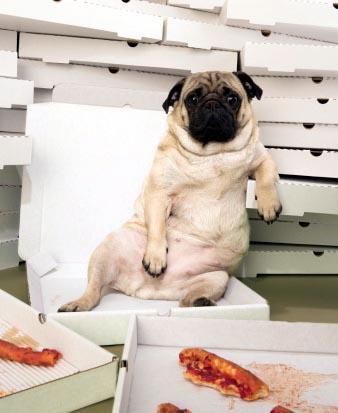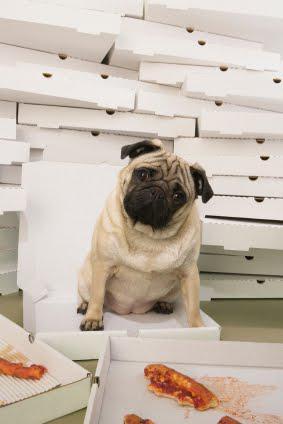The first image is the image on the left, the second image is the image on the right. Examine the images to the left and right. Is the description "There is a pug eating a slice of pizza, and another pug not eating a slice of pizza." accurate? Answer yes or no. No. The first image is the image on the left, the second image is the image on the right. For the images displayed, is the sentence "An image shows a pug with a propped elbow reclining in an open white box in front of stacks of white boxes." factually correct? Answer yes or no. Yes. 